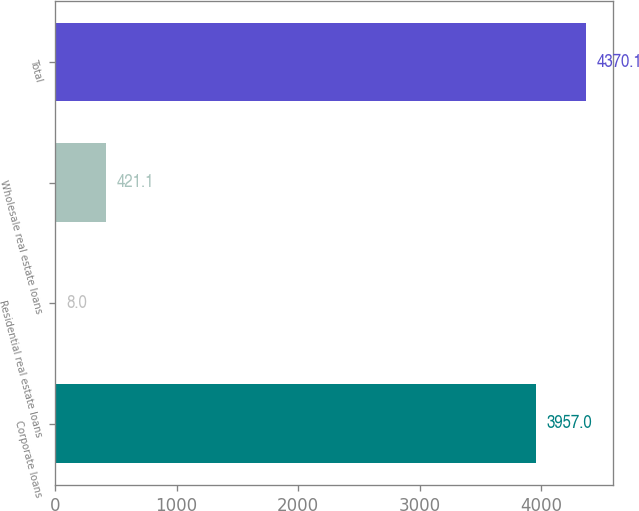<chart> <loc_0><loc_0><loc_500><loc_500><bar_chart><fcel>Corporate loans<fcel>Residential real estate loans<fcel>Wholesale real estate loans<fcel>Total<nl><fcel>3957<fcel>8<fcel>421.1<fcel>4370.1<nl></chart> 